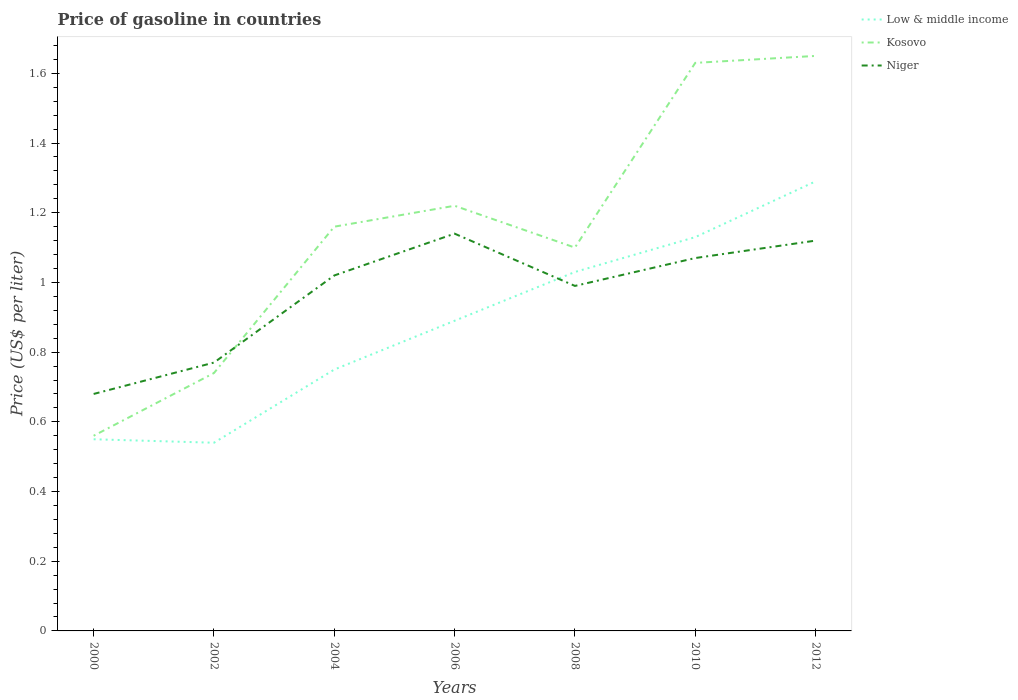Across all years, what is the maximum price of gasoline in Low & middle income?
Offer a very short reply. 0.54. In which year was the price of gasoline in Low & middle income maximum?
Provide a succinct answer. 2002. What is the total price of gasoline in Niger in the graph?
Your answer should be very brief. 0.07. What is the difference between the highest and the second highest price of gasoline in Niger?
Provide a succinct answer. 0.46. What is the difference between the highest and the lowest price of gasoline in Niger?
Provide a succinct answer. 5. Is the price of gasoline in Niger strictly greater than the price of gasoline in Low & middle income over the years?
Provide a short and direct response. No. How many lines are there?
Provide a short and direct response. 3. How many years are there in the graph?
Your answer should be compact. 7. Does the graph contain any zero values?
Make the answer very short. No. Where does the legend appear in the graph?
Ensure brevity in your answer.  Top right. How many legend labels are there?
Your answer should be very brief. 3. How are the legend labels stacked?
Ensure brevity in your answer.  Vertical. What is the title of the graph?
Provide a short and direct response. Price of gasoline in countries. Does "Jamaica" appear as one of the legend labels in the graph?
Your answer should be very brief. No. What is the label or title of the Y-axis?
Give a very brief answer. Price (US$ per liter). What is the Price (US$ per liter) in Low & middle income in 2000?
Make the answer very short. 0.55. What is the Price (US$ per liter) of Kosovo in 2000?
Offer a terse response. 0.56. What is the Price (US$ per liter) of Niger in 2000?
Offer a very short reply. 0.68. What is the Price (US$ per liter) in Low & middle income in 2002?
Keep it short and to the point. 0.54. What is the Price (US$ per liter) in Kosovo in 2002?
Ensure brevity in your answer.  0.74. What is the Price (US$ per liter) in Niger in 2002?
Provide a succinct answer. 0.77. What is the Price (US$ per liter) of Low & middle income in 2004?
Your answer should be very brief. 0.75. What is the Price (US$ per liter) of Kosovo in 2004?
Your answer should be very brief. 1.16. What is the Price (US$ per liter) in Niger in 2004?
Keep it short and to the point. 1.02. What is the Price (US$ per liter) in Low & middle income in 2006?
Your answer should be compact. 0.89. What is the Price (US$ per liter) in Kosovo in 2006?
Make the answer very short. 1.22. What is the Price (US$ per liter) of Niger in 2006?
Ensure brevity in your answer.  1.14. What is the Price (US$ per liter) in Niger in 2008?
Give a very brief answer. 0.99. What is the Price (US$ per liter) of Low & middle income in 2010?
Make the answer very short. 1.13. What is the Price (US$ per liter) in Kosovo in 2010?
Give a very brief answer. 1.63. What is the Price (US$ per liter) of Niger in 2010?
Make the answer very short. 1.07. What is the Price (US$ per liter) of Low & middle income in 2012?
Ensure brevity in your answer.  1.29. What is the Price (US$ per liter) of Kosovo in 2012?
Ensure brevity in your answer.  1.65. What is the Price (US$ per liter) in Niger in 2012?
Your answer should be very brief. 1.12. Across all years, what is the maximum Price (US$ per liter) in Low & middle income?
Keep it short and to the point. 1.29. Across all years, what is the maximum Price (US$ per liter) of Kosovo?
Offer a very short reply. 1.65. Across all years, what is the maximum Price (US$ per liter) of Niger?
Make the answer very short. 1.14. Across all years, what is the minimum Price (US$ per liter) in Low & middle income?
Your answer should be compact. 0.54. Across all years, what is the minimum Price (US$ per liter) in Kosovo?
Your response must be concise. 0.56. Across all years, what is the minimum Price (US$ per liter) of Niger?
Offer a terse response. 0.68. What is the total Price (US$ per liter) of Low & middle income in the graph?
Provide a short and direct response. 6.18. What is the total Price (US$ per liter) of Kosovo in the graph?
Your response must be concise. 8.06. What is the total Price (US$ per liter) of Niger in the graph?
Your answer should be very brief. 6.79. What is the difference between the Price (US$ per liter) of Low & middle income in 2000 and that in 2002?
Ensure brevity in your answer.  0.01. What is the difference between the Price (US$ per liter) in Kosovo in 2000 and that in 2002?
Ensure brevity in your answer.  -0.18. What is the difference between the Price (US$ per liter) of Niger in 2000 and that in 2002?
Ensure brevity in your answer.  -0.09. What is the difference between the Price (US$ per liter) of Kosovo in 2000 and that in 2004?
Make the answer very short. -0.6. What is the difference between the Price (US$ per liter) of Niger in 2000 and that in 2004?
Offer a very short reply. -0.34. What is the difference between the Price (US$ per liter) of Low & middle income in 2000 and that in 2006?
Provide a short and direct response. -0.34. What is the difference between the Price (US$ per liter) of Kosovo in 2000 and that in 2006?
Offer a very short reply. -0.66. What is the difference between the Price (US$ per liter) in Niger in 2000 and that in 2006?
Offer a very short reply. -0.46. What is the difference between the Price (US$ per liter) of Low & middle income in 2000 and that in 2008?
Your answer should be very brief. -0.48. What is the difference between the Price (US$ per liter) in Kosovo in 2000 and that in 2008?
Your response must be concise. -0.54. What is the difference between the Price (US$ per liter) of Niger in 2000 and that in 2008?
Ensure brevity in your answer.  -0.31. What is the difference between the Price (US$ per liter) of Low & middle income in 2000 and that in 2010?
Give a very brief answer. -0.58. What is the difference between the Price (US$ per liter) in Kosovo in 2000 and that in 2010?
Your answer should be very brief. -1.07. What is the difference between the Price (US$ per liter) in Niger in 2000 and that in 2010?
Your answer should be compact. -0.39. What is the difference between the Price (US$ per liter) in Low & middle income in 2000 and that in 2012?
Your answer should be compact. -0.74. What is the difference between the Price (US$ per liter) of Kosovo in 2000 and that in 2012?
Make the answer very short. -1.09. What is the difference between the Price (US$ per liter) of Niger in 2000 and that in 2012?
Provide a short and direct response. -0.44. What is the difference between the Price (US$ per liter) of Low & middle income in 2002 and that in 2004?
Give a very brief answer. -0.21. What is the difference between the Price (US$ per liter) in Kosovo in 2002 and that in 2004?
Ensure brevity in your answer.  -0.42. What is the difference between the Price (US$ per liter) in Low & middle income in 2002 and that in 2006?
Your answer should be compact. -0.35. What is the difference between the Price (US$ per liter) in Kosovo in 2002 and that in 2006?
Give a very brief answer. -0.48. What is the difference between the Price (US$ per liter) in Niger in 2002 and that in 2006?
Your answer should be compact. -0.37. What is the difference between the Price (US$ per liter) of Low & middle income in 2002 and that in 2008?
Your response must be concise. -0.49. What is the difference between the Price (US$ per liter) of Kosovo in 2002 and that in 2008?
Provide a succinct answer. -0.36. What is the difference between the Price (US$ per liter) in Niger in 2002 and that in 2008?
Your answer should be very brief. -0.22. What is the difference between the Price (US$ per liter) in Low & middle income in 2002 and that in 2010?
Give a very brief answer. -0.59. What is the difference between the Price (US$ per liter) of Kosovo in 2002 and that in 2010?
Keep it short and to the point. -0.89. What is the difference between the Price (US$ per liter) of Low & middle income in 2002 and that in 2012?
Give a very brief answer. -0.75. What is the difference between the Price (US$ per liter) in Kosovo in 2002 and that in 2012?
Provide a short and direct response. -0.91. What is the difference between the Price (US$ per liter) of Niger in 2002 and that in 2012?
Provide a short and direct response. -0.35. What is the difference between the Price (US$ per liter) in Low & middle income in 2004 and that in 2006?
Offer a very short reply. -0.14. What is the difference between the Price (US$ per liter) in Kosovo in 2004 and that in 2006?
Your response must be concise. -0.06. What is the difference between the Price (US$ per liter) of Niger in 2004 and that in 2006?
Your answer should be compact. -0.12. What is the difference between the Price (US$ per liter) in Low & middle income in 2004 and that in 2008?
Provide a succinct answer. -0.28. What is the difference between the Price (US$ per liter) in Kosovo in 2004 and that in 2008?
Ensure brevity in your answer.  0.06. What is the difference between the Price (US$ per liter) in Low & middle income in 2004 and that in 2010?
Offer a very short reply. -0.38. What is the difference between the Price (US$ per liter) in Kosovo in 2004 and that in 2010?
Offer a terse response. -0.47. What is the difference between the Price (US$ per liter) of Low & middle income in 2004 and that in 2012?
Your answer should be very brief. -0.54. What is the difference between the Price (US$ per liter) in Kosovo in 2004 and that in 2012?
Ensure brevity in your answer.  -0.49. What is the difference between the Price (US$ per liter) in Niger in 2004 and that in 2012?
Offer a terse response. -0.1. What is the difference between the Price (US$ per liter) in Low & middle income in 2006 and that in 2008?
Keep it short and to the point. -0.14. What is the difference between the Price (US$ per liter) of Kosovo in 2006 and that in 2008?
Offer a very short reply. 0.12. What is the difference between the Price (US$ per liter) of Low & middle income in 2006 and that in 2010?
Offer a terse response. -0.24. What is the difference between the Price (US$ per liter) in Kosovo in 2006 and that in 2010?
Keep it short and to the point. -0.41. What is the difference between the Price (US$ per liter) of Niger in 2006 and that in 2010?
Keep it short and to the point. 0.07. What is the difference between the Price (US$ per liter) of Kosovo in 2006 and that in 2012?
Your answer should be compact. -0.43. What is the difference between the Price (US$ per liter) of Low & middle income in 2008 and that in 2010?
Ensure brevity in your answer.  -0.1. What is the difference between the Price (US$ per liter) of Kosovo in 2008 and that in 2010?
Make the answer very short. -0.53. What is the difference between the Price (US$ per liter) in Niger in 2008 and that in 2010?
Keep it short and to the point. -0.08. What is the difference between the Price (US$ per liter) in Low & middle income in 2008 and that in 2012?
Make the answer very short. -0.26. What is the difference between the Price (US$ per liter) of Kosovo in 2008 and that in 2012?
Ensure brevity in your answer.  -0.55. What is the difference between the Price (US$ per liter) of Niger in 2008 and that in 2012?
Provide a short and direct response. -0.13. What is the difference between the Price (US$ per liter) of Low & middle income in 2010 and that in 2012?
Ensure brevity in your answer.  -0.16. What is the difference between the Price (US$ per liter) in Kosovo in 2010 and that in 2012?
Make the answer very short. -0.02. What is the difference between the Price (US$ per liter) in Low & middle income in 2000 and the Price (US$ per liter) in Kosovo in 2002?
Give a very brief answer. -0.19. What is the difference between the Price (US$ per liter) of Low & middle income in 2000 and the Price (US$ per liter) of Niger in 2002?
Your answer should be very brief. -0.22. What is the difference between the Price (US$ per liter) in Kosovo in 2000 and the Price (US$ per liter) in Niger in 2002?
Offer a very short reply. -0.21. What is the difference between the Price (US$ per liter) in Low & middle income in 2000 and the Price (US$ per liter) in Kosovo in 2004?
Your answer should be very brief. -0.61. What is the difference between the Price (US$ per liter) of Low & middle income in 2000 and the Price (US$ per liter) of Niger in 2004?
Keep it short and to the point. -0.47. What is the difference between the Price (US$ per liter) in Kosovo in 2000 and the Price (US$ per liter) in Niger in 2004?
Provide a succinct answer. -0.46. What is the difference between the Price (US$ per liter) of Low & middle income in 2000 and the Price (US$ per liter) of Kosovo in 2006?
Give a very brief answer. -0.67. What is the difference between the Price (US$ per liter) in Low & middle income in 2000 and the Price (US$ per liter) in Niger in 2006?
Make the answer very short. -0.59. What is the difference between the Price (US$ per liter) of Kosovo in 2000 and the Price (US$ per liter) of Niger in 2006?
Give a very brief answer. -0.58. What is the difference between the Price (US$ per liter) in Low & middle income in 2000 and the Price (US$ per liter) in Kosovo in 2008?
Give a very brief answer. -0.55. What is the difference between the Price (US$ per liter) in Low & middle income in 2000 and the Price (US$ per liter) in Niger in 2008?
Your answer should be compact. -0.44. What is the difference between the Price (US$ per liter) in Kosovo in 2000 and the Price (US$ per liter) in Niger in 2008?
Ensure brevity in your answer.  -0.43. What is the difference between the Price (US$ per liter) of Low & middle income in 2000 and the Price (US$ per liter) of Kosovo in 2010?
Provide a short and direct response. -1.08. What is the difference between the Price (US$ per liter) of Low & middle income in 2000 and the Price (US$ per liter) of Niger in 2010?
Your answer should be very brief. -0.52. What is the difference between the Price (US$ per liter) in Kosovo in 2000 and the Price (US$ per liter) in Niger in 2010?
Give a very brief answer. -0.51. What is the difference between the Price (US$ per liter) of Low & middle income in 2000 and the Price (US$ per liter) of Kosovo in 2012?
Provide a succinct answer. -1.1. What is the difference between the Price (US$ per liter) of Low & middle income in 2000 and the Price (US$ per liter) of Niger in 2012?
Make the answer very short. -0.57. What is the difference between the Price (US$ per liter) in Kosovo in 2000 and the Price (US$ per liter) in Niger in 2012?
Provide a short and direct response. -0.56. What is the difference between the Price (US$ per liter) of Low & middle income in 2002 and the Price (US$ per liter) of Kosovo in 2004?
Provide a succinct answer. -0.62. What is the difference between the Price (US$ per liter) in Low & middle income in 2002 and the Price (US$ per liter) in Niger in 2004?
Your answer should be very brief. -0.48. What is the difference between the Price (US$ per liter) in Kosovo in 2002 and the Price (US$ per liter) in Niger in 2004?
Ensure brevity in your answer.  -0.28. What is the difference between the Price (US$ per liter) in Low & middle income in 2002 and the Price (US$ per liter) in Kosovo in 2006?
Offer a very short reply. -0.68. What is the difference between the Price (US$ per liter) in Low & middle income in 2002 and the Price (US$ per liter) in Kosovo in 2008?
Provide a short and direct response. -0.56. What is the difference between the Price (US$ per liter) in Low & middle income in 2002 and the Price (US$ per liter) in Niger in 2008?
Ensure brevity in your answer.  -0.45. What is the difference between the Price (US$ per liter) of Low & middle income in 2002 and the Price (US$ per liter) of Kosovo in 2010?
Your response must be concise. -1.09. What is the difference between the Price (US$ per liter) in Low & middle income in 2002 and the Price (US$ per liter) in Niger in 2010?
Offer a terse response. -0.53. What is the difference between the Price (US$ per liter) of Kosovo in 2002 and the Price (US$ per liter) of Niger in 2010?
Provide a succinct answer. -0.33. What is the difference between the Price (US$ per liter) of Low & middle income in 2002 and the Price (US$ per liter) of Kosovo in 2012?
Make the answer very short. -1.11. What is the difference between the Price (US$ per liter) of Low & middle income in 2002 and the Price (US$ per liter) of Niger in 2012?
Provide a short and direct response. -0.58. What is the difference between the Price (US$ per liter) in Kosovo in 2002 and the Price (US$ per liter) in Niger in 2012?
Your answer should be very brief. -0.38. What is the difference between the Price (US$ per liter) in Low & middle income in 2004 and the Price (US$ per liter) in Kosovo in 2006?
Your answer should be very brief. -0.47. What is the difference between the Price (US$ per liter) in Low & middle income in 2004 and the Price (US$ per liter) in Niger in 2006?
Keep it short and to the point. -0.39. What is the difference between the Price (US$ per liter) in Low & middle income in 2004 and the Price (US$ per liter) in Kosovo in 2008?
Give a very brief answer. -0.35. What is the difference between the Price (US$ per liter) in Low & middle income in 2004 and the Price (US$ per liter) in Niger in 2008?
Your answer should be very brief. -0.24. What is the difference between the Price (US$ per liter) of Kosovo in 2004 and the Price (US$ per liter) of Niger in 2008?
Provide a short and direct response. 0.17. What is the difference between the Price (US$ per liter) of Low & middle income in 2004 and the Price (US$ per liter) of Kosovo in 2010?
Your response must be concise. -0.88. What is the difference between the Price (US$ per liter) in Low & middle income in 2004 and the Price (US$ per liter) in Niger in 2010?
Offer a terse response. -0.32. What is the difference between the Price (US$ per liter) of Kosovo in 2004 and the Price (US$ per liter) of Niger in 2010?
Give a very brief answer. 0.09. What is the difference between the Price (US$ per liter) in Low & middle income in 2004 and the Price (US$ per liter) in Niger in 2012?
Ensure brevity in your answer.  -0.37. What is the difference between the Price (US$ per liter) in Low & middle income in 2006 and the Price (US$ per liter) in Kosovo in 2008?
Provide a succinct answer. -0.21. What is the difference between the Price (US$ per liter) of Kosovo in 2006 and the Price (US$ per liter) of Niger in 2008?
Make the answer very short. 0.23. What is the difference between the Price (US$ per liter) of Low & middle income in 2006 and the Price (US$ per liter) of Kosovo in 2010?
Ensure brevity in your answer.  -0.74. What is the difference between the Price (US$ per liter) in Low & middle income in 2006 and the Price (US$ per liter) in Niger in 2010?
Provide a short and direct response. -0.18. What is the difference between the Price (US$ per liter) in Low & middle income in 2006 and the Price (US$ per liter) in Kosovo in 2012?
Make the answer very short. -0.76. What is the difference between the Price (US$ per liter) in Low & middle income in 2006 and the Price (US$ per liter) in Niger in 2012?
Provide a succinct answer. -0.23. What is the difference between the Price (US$ per liter) of Kosovo in 2006 and the Price (US$ per liter) of Niger in 2012?
Your answer should be compact. 0.1. What is the difference between the Price (US$ per liter) in Low & middle income in 2008 and the Price (US$ per liter) in Niger in 2010?
Your answer should be compact. -0.04. What is the difference between the Price (US$ per liter) of Low & middle income in 2008 and the Price (US$ per liter) of Kosovo in 2012?
Give a very brief answer. -0.62. What is the difference between the Price (US$ per liter) in Low & middle income in 2008 and the Price (US$ per liter) in Niger in 2012?
Make the answer very short. -0.09. What is the difference between the Price (US$ per liter) in Kosovo in 2008 and the Price (US$ per liter) in Niger in 2012?
Make the answer very short. -0.02. What is the difference between the Price (US$ per liter) of Low & middle income in 2010 and the Price (US$ per liter) of Kosovo in 2012?
Offer a terse response. -0.52. What is the difference between the Price (US$ per liter) of Low & middle income in 2010 and the Price (US$ per liter) of Niger in 2012?
Your response must be concise. 0.01. What is the difference between the Price (US$ per liter) of Kosovo in 2010 and the Price (US$ per liter) of Niger in 2012?
Provide a succinct answer. 0.51. What is the average Price (US$ per liter) in Low & middle income per year?
Make the answer very short. 0.88. What is the average Price (US$ per liter) in Kosovo per year?
Make the answer very short. 1.15. What is the average Price (US$ per liter) in Niger per year?
Give a very brief answer. 0.97. In the year 2000, what is the difference between the Price (US$ per liter) in Low & middle income and Price (US$ per liter) in Kosovo?
Provide a short and direct response. -0.01. In the year 2000, what is the difference between the Price (US$ per liter) of Low & middle income and Price (US$ per liter) of Niger?
Keep it short and to the point. -0.13. In the year 2000, what is the difference between the Price (US$ per liter) in Kosovo and Price (US$ per liter) in Niger?
Make the answer very short. -0.12. In the year 2002, what is the difference between the Price (US$ per liter) of Low & middle income and Price (US$ per liter) of Kosovo?
Give a very brief answer. -0.2. In the year 2002, what is the difference between the Price (US$ per liter) of Low & middle income and Price (US$ per liter) of Niger?
Your answer should be compact. -0.23. In the year 2002, what is the difference between the Price (US$ per liter) of Kosovo and Price (US$ per liter) of Niger?
Offer a very short reply. -0.03. In the year 2004, what is the difference between the Price (US$ per liter) of Low & middle income and Price (US$ per liter) of Kosovo?
Give a very brief answer. -0.41. In the year 2004, what is the difference between the Price (US$ per liter) of Low & middle income and Price (US$ per liter) of Niger?
Give a very brief answer. -0.27. In the year 2004, what is the difference between the Price (US$ per liter) of Kosovo and Price (US$ per liter) of Niger?
Keep it short and to the point. 0.14. In the year 2006, what is the difference between the Price (US$ per liter) of Low & middle income and Price (US$ per liter) of Kosovo?
Offer a terse response. -0.33. In the year 2006, what is the difference between the Price (US$ per liter) of Kosovo and Price (US$ per liter) of Niger?
Offer a very short reply. 0.08. In the year 2008, what is the difference between the Price (US$ per liter) of Low & middle income and Price (US$ per liter) of Kosovo?
Keep it short and to the point. -0.07. In the year 2008, what is the difference between the Price (US$ per liter) of Low & middle income and Price (US$ per liter) of Niger?
Your answer should be very brief. 0.04. In the year 2008, what is the difference between the Price (US$ per liter) in Kosovo and Price (US$ per liter) in Niger?
Ensure brevity in your answer.  0.11. In the year 2010, what is the difference between the Price (US$ per liter) of Kosovo and Price (US$ per liter) of Niger?
Your answer should be compact. 0.56. In the year 2012, what is the difference between the Price (US$ per liter) in Low & middle income and Price (US$ per liter) in Kosovo?
Offer a terse response. -0.36. In the year 2012, what is the difference between the Price (US$ per liter) in Low & middle income and Price (US$ per liter) in Niger?
Give a very brief answer. 0.17. In the year 2012, what is the difference between the Price (US$ per liter) of Kosovo and Price (US$ per liter) of Niger?
Provide a succinct answer. 0.53. What is the ratio of the Price (US$ per liter) of Low & middle income in 2000 to that in 2002?
Provide a short and direct response. 1.02. What is the ratio of the Price (US$ per liter) of Kosovo in 2000 to that in 2002?
Ensure brevity in your answer.  0.76. What is the ratio of the Price (US$ per liter) in Niger in 2000 to that in 2002?
Keep it short and to the point. 0.88. What is the ratio of the Price (US$ per liter) of Low & middle income in 2000 to that in 2004?
Ensure brevity in your answer.  0.73. What is the ratio of the Price (US$ per liter) of Kosovo in 2000 to that in 2004?
Offer a very short reply. 0.48. What is the ratio of the Price (US$ per liter) in Low & middle income in 2000 to that in 2006?
Offer a very short reply. 0.62. What is the ratio of the Price (US$ per liter) in Kosovo in 2000 to that in 2006?
Your response must be concise. 0.46. What is the ratio of the Price (US$ per liter) of Niger in 2000 to that in 2006?
Provide a short and direct response. 0.6. What is the ratio of the Price (US$ per liter) in Low & middle income in 2000 to that in 2008?
Keep it short and to the point. 0.53. What is the ratio of the Price (US$ per liter) of Kosovo in 2000 to that in 2008?
Your response must be concise. 0.51. What is the ratio of the Price (US$ per liter) in Niger in 2000 to that in 2008?
Offer a very short reply. 0.69. What is the ratio of the Price (US$ per liter) of Low & middle income in 2000 to that in 2010?
Offer a terse response. 0.49. What is the ratio of the Price (US$ per liter) of Kosovo in 2000 to that in 2010?
Make the answer very short. 0.34. What is the ratio of the Price (US$ per liter) in Niger in 2000 to that in 2010?
Your answer should be very brief. 0.64. What is the ratio of the Price (US$ per liter) of Low & middle income in 2000 to that in 2012?
Provide a succinct answer. 0.43. What is the ratio of the Price (US$ per liter) in Kosovo in 2000 to that in 2012?
Offer a very short reply. 0.34. What is the ratio of the Price (US$ per liter) in Niger in 2000 to that in 2012?
Keep it short and to the point. 0.61. What is the ratio of the Price (US$ per liter) in Low & middle income in 2002 to that in 2004?
Give a very brief answer. 0.72. What is the ratio of the Price (US$ per liter) in Kosovo in 2002 to that in 2004?
Your answer should be very brief. 0.64. What is the ratio of the Price (US$ per liter) in Niger in 2002 to that in 2004?
Your answer should be compact. 0.75. What is the ratio of the Price (US$ per liter) of Low & middle income in 2002 to that in 2006?
Offer a terse response. 0.61. What is the ratio of the Price (US$ per liter) in Kosovo in 2002 to that in 2006?
Ensure brevity in your answer.  0.61. What is the ratio of the Price (US$ per liter) of Niger in 2002 to that in 2006?
Offer a very short reply. 0.68. What is the ratio of the Price (US$ per liter) of Low & middle income in 2002 to that in 2008?
Provide a short and direct response. 0.52. What is the ratio of the Price (US$ per liter) in Kosovo in 2002 to that in 2008?
Keep it short and to the point. 0.67. What is the ratio of the Price (US$ per liter) in Low & middle income in 2002 to that in 2010?
Provide a short and direct response. 0.48. What is the ratio of the Price (US$ per liter) in Kosovo in 2002 to that in 2010?
Keep it short and to the point. 0.45. What is the ratio of the Price (US$ per liter) in Niger in 2002 to that in 2010?
Keep it short and to the point. 0.72. What is the ratio of the Price (US$ per liter) in Low & middle income in 2002 to that in 2012?
Your response must be concise. 0.42. What is the ratio of the Price (US$ per liter) of Kosovo in 2002 to that in 2012?
Your response must be concise. 0.45. What is the ratio of the Price (US$ per liter) of Niger in 2002 to that in 2012?
Provide a succinct answer. 0.69. What is the ratio of the Price (US$ per liter) of Low & middle income in 2004 to that in 2006?
Keep it short and to the point. 0.84. What is the ratio of the Price (US$ per liter) in Kosovo in 2004 to that in 2006?
Provide a short and direct response. 0.95. What is the ratio of the Price (US$ per liter) of Niger in 2004 to that in 2006?
Give a very brief answer. 0.89. What is the ratio of the Price (US$ per liter) in Low & middle income in 2004 to that in 2008?
Your answer should be very brief. 0.73. What is the ratio of the Price (US$ per liter) in Kosovo in 2004 to that in 2008?
Your answer should be very brief. 1.05. What is the ratio of the Price (US$ per liter) of Niger in 2004 to that in 2008?
Your answer should be very brief. 1.03. What is the ratio of the Price (US$ per liter) of Low & middle income in 2004 to that in 2010?
Provide a succinct answer. 0.66. What is the ratio of the Price (US$ per liter) in Kosovo in 2004 to that in 2010?
Offer a very short reply. 0.71. What is the ratio of the Price (US$ per liter) in Niger in 2004 to that in 2010?
Make the answer very short. 0.95. What is the ratio of the Price (US$ per liter) in Low & middle income in 2004 to that in 2012?
Make the answer very short. 0.58. What is the ratio of the Price (US$ per liter) in Kosovo in 2004 to that in 2012?
Your answer should be very brief. 0.7. What is the ratio of the Price (US$ per liter) of Niger in 2004 to that in 2012?
Your answer should be very brief. 0.91. What is the ratio of the Price (US$ per liter) in Low & middle income in 2006 to that in 2008?
Your response must be concise. 0.86. What is the ratio of the Price (US$ per liter) of Kosovo in 2006 to that in 2008?
Make the answer very short. 1.11. What is the ratio of the Price (US$ per liter) of Niger in 2006 to that in 2008?
Provide a short and direct response. 1.15. What is the ratio of the Price (US$ per liter) of Low & middle income in 2006 to that in 2010?
Your answer should be very brief. 0.79. What is the ratio of the Price (US$ per liter) of Kosovo in 2006 to that in 2010?
Your response must be concise. 0.75. What is the ratio of the Price (US$ per liter) of Niger in 2006 to that in 2010?
Provide a short and direct response. 1.07. What is the ratio of the Price (US$ per liter) in Low & middle income in 2006 to that in 2012?
Ensure brevity in your answer.  0.69. What is the ratio of the Price (US$ per liter) of Kosovo in 2006 to that in 2012?
Offer a terse response. 0.74. What is the ratio of the Price (US$ per liter) in Niger in 2006 to that in 2012?
Your response must be concise. 1.02. What is the ratio of the Price (US$ per liter) of Low & middle income in 2008 to that in 2010?
Provide a succinct answer. 0.91. What is the ratio of the Price (US$ per liter) in Kosovo in 2008 to that in 2010?
Your response must be concise. 0.67. What is the ratio of the Price (US$ per liter) in Niger in 2008 to that in 2010?
Provide a short and direct response. 0.93. What is the ratio of the Price (US$ per liter) of Low & middle income in 2008 to that in 2012?
Offer a terse response. 0.8. What is the ratio of the Price (US$ per liter) of Niger in 2008 to that in 2012?
Provide a succinct answer. 0.88. What is the ratio of the Price (US$ per liter) of Low & middle income in 2010 to that in 2012?
Offer a very short reply. 0.88. What is the ratio of the Price (US$ per liter) of Kosovo in 2010 to that in 2012?
Ensure brevity in your answer.  0.99. What is the ratio of the Price (US$ per liter) in Niger in 2010 to that in 2012?
Make the answer very short. 0.96. What is the difference between the highest and the second highest Price (US$ per liter) in Low & middle income?
Offer a very short reply. 0.16. What is the difference between the highest and the second highest Price (US$ per liter) in Kosovo?
Offer a terse response. 0.02. What is the difference between the highest and the lowest Price (US$ per liter) in Kosovo?
Your answer should be compact. 1.09. What is the difference between the highest and the lowest Price (US$ per liter) in Niger?
Your answer should be compact. 0.46. 